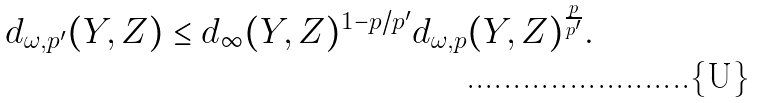<formula> <loc_0><loc_0><loc_500><loc_500>d _ { \omega , p ^ { \prime } } ( Y , Z ) \leq d _ { \infty } ( Y , Z ) ^ { 1 - p / p ^ { \prime } } d _ { \omega , p } ( Y , Z ) ^ { \frac { p } { p ^ { \prime } } } .</formula> 